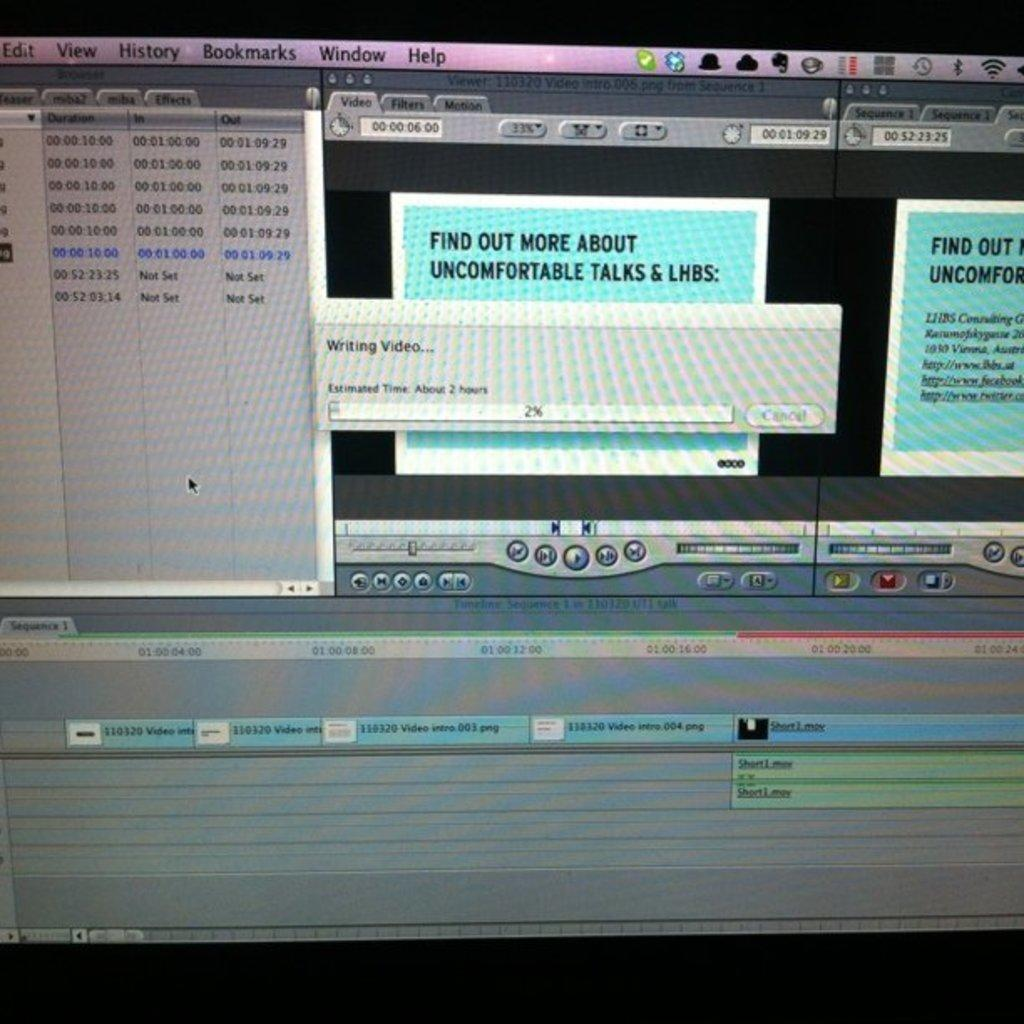<image>
Share a concise interpretation of the image provided. Computer screen showing the progress for writing a video. 